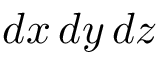<formula> <loc_0><loc_0><loc_500><loc_500>d x \, d y \, d z</formula> 